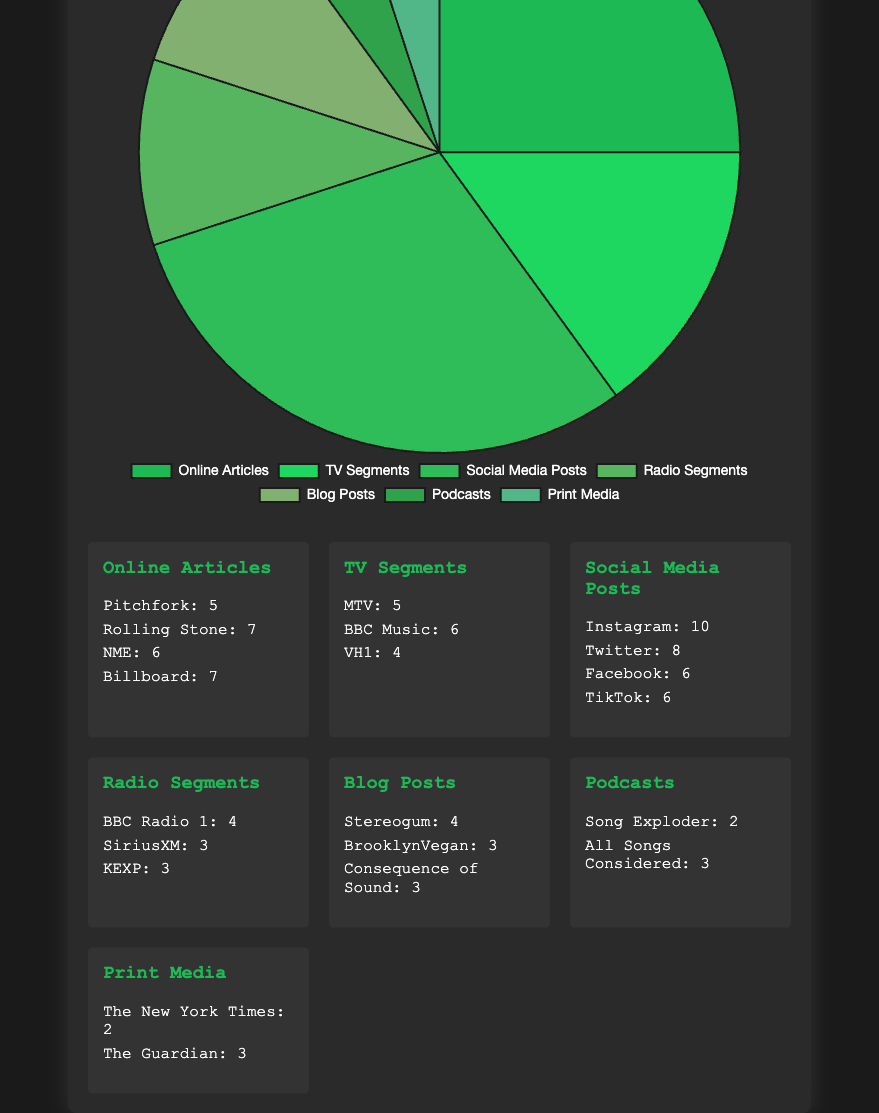Which type of media coverage had the highest number of occurrences? By looking at the sizes of the segments in the pie chart, the largest segment corresponds to Social Media Posts. This indicates that Social Media Posts had the highest number with 30 occurrences.
Answer: Social Media Posts Which platform had the highest number of Social Media Posts? Under the Social Media Posts detail section, Instagram has the highest count with 10 posts.
Answer: Instagram How many more Online Articles were there compared to Radio Segments? Online Articles had 25 occurrences, while Radio Segments had 10 occurrences. The difference is 25 - 10 = 15.
Answer: 15 What is the total number of occurrences for Blog Posts and Podcasts combined? Blog Posts had 10 occurrences and Podcasts had 5 occurrences. The total is 10 + 5 = 15.
Answer: 15 Which two sources contributed the least to the coverage, and how many occurrences did they have? By checking the details, Podcasts (Song Exploder with 2 occurrences) and Print Media (The New York Times with 2 occurrences) had the least coverage.
Answer: Song Exploder and The New York Times, 2 occurrences each How many more occurrences did Rolling Stone have compared to Billboard for Online Articles? Rolling Stone had 7 occurrences, and Billboard had 7 as well. Therefore, they had an equal number.
Answer: 0 Arrange the sources of TV Segments from most occurrences to least. Referencing the details under TV Segments, BBC Music had 6, MTV had 5, and VH1 had 4 occurrences. Thus, the order is: BBC Music, MTV, VH1.
Answer: BBC Music, MTV, VH1 Which categories have the same number of occurrences, and what is that number? From the values in the pie chart, Radio Segments and Blog Posts each have 10 occurrences, and Podcasts and Print Media each have 5 occurrences.
Answer: Radio Segments and Blog Posts: 10, Podcasts and Print Media: 5 What is the average number of occurrences per media category? Sum all the values (25 + 15 + 30 + 10 + 10 + 5 + 5 = 100) and divide by the number of categories (7), the average is 100 / 7 ≈ 14.29.
Answer: 14.29 How many total media coverages were recorded? Adding all occurrences together (25 + 15 + 30 + 10 + 10 + 5 + 5) results in a total of 100.
Answer: 100 